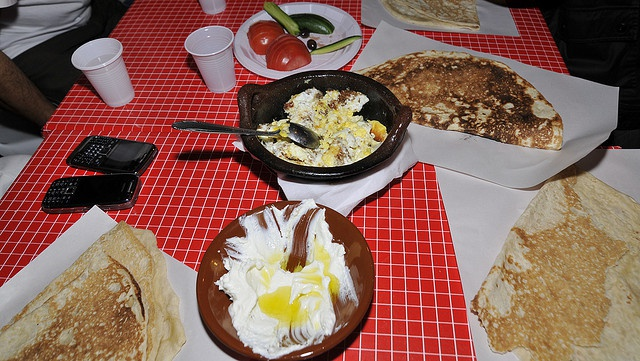Describe the objects in this image and their specific colors. I can see dining table in darkgray, tan, brown, and lightgray tones, dining table in darkgray, brown, and maroon tones, bowl in darkgray, black, beige, lightgray, and tan tones, bowl in darkgray, maroon, black, brown, and gray tones, and cell phone in darkgray, black, maroon, brown, and gray tones in this image. 